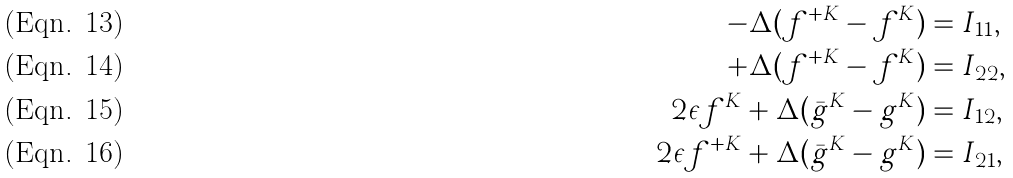Convert formula to latex. <formula><loc_0><loc_0><loc_500><loc_500>- \Delta ( f ^ { + K } - f ^ { K } ) & = I _ { 1 1 } , \\ + \Delta ( f ^ { + K } - f ^ { K } ) & = I _ { 2 2 } , \\ 2 \epsilon f ^ { K } + \Delta ( \bar { g } ^ { K } - g ^ { K } ) & = I _ { 1 2 } , \\ 2 \epsilon f ^ { + K } + \Delta ( \bar { g } ^ { K } - g ^ { K } ) & = I _ { 2 1 } ,</formula> 